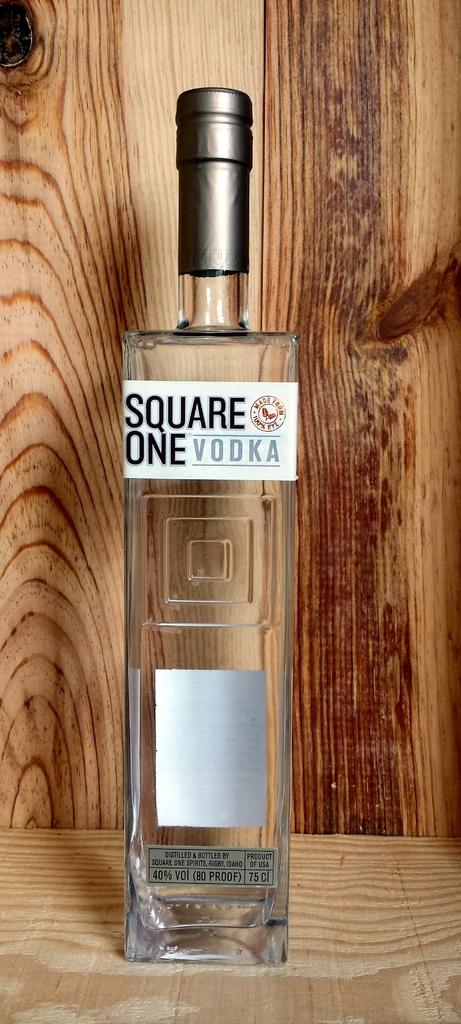Is this vodka?
Provide a short and direct response. Yes. 